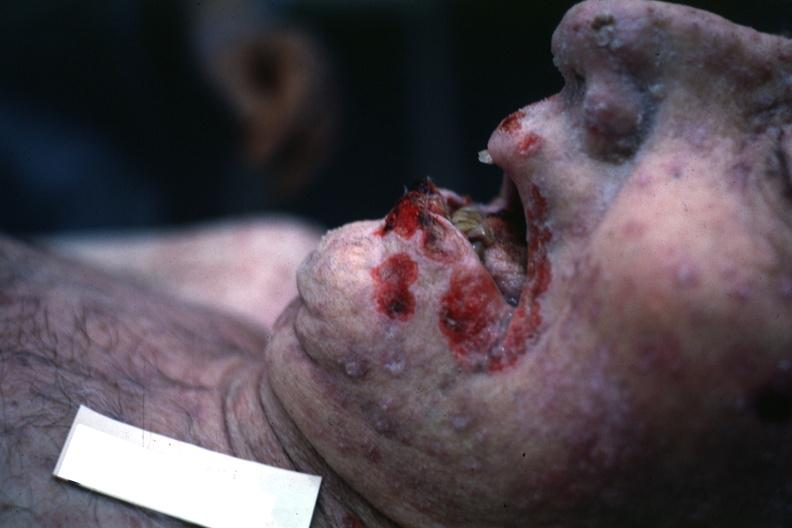s lip present?
Answer the question using a single word or phrase. Yes 